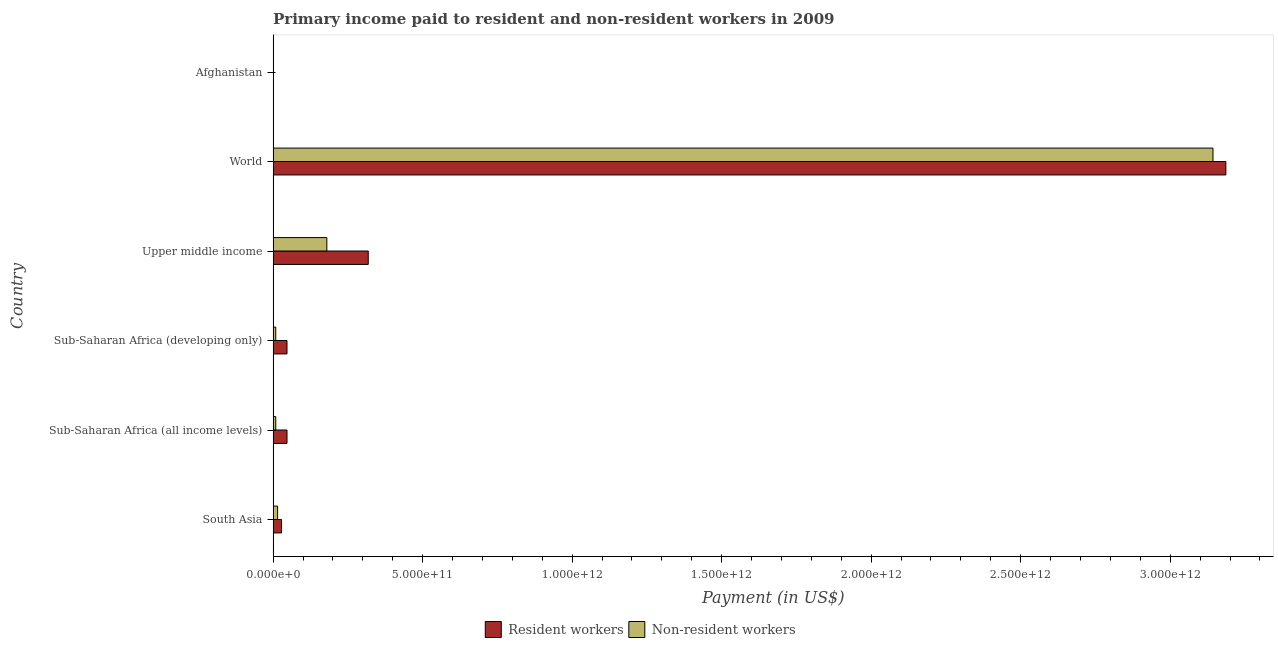How many groups of bars are there?
Offer a very short reply. 6. How many bars are there on the 1st tick from the top?
Provide a short and direct response. 2. What is the label of the 1st group of bars from the top?
Keep it short and to the point. Afghanistan. In how many cases, is the number of bars for a given country not equal to the number of legend labels?
Ensure brevity in your answer.  0. What is the payment made to non-resident workers in Sub-Saharan Africa (all income levels)?
Your response must be concise. 8.85e+09. Across all countries, what is the maximum payment made to resident workers?
Your answer should be very brief. 3.19e+12. Across all countries, what is the minimum payment made to resident workers?
Keep it short and to the point. 1.66e+08. In which country was the payment made to non-resident workers maximum?
Keep it short and to the point. World. In which country was the payment made to non-resident workers minimum?
Give a very brief answer. Afghanistan. What is the total payment made to resident workers in the graph?
Your answer should be very brief. 3.63e+12. What is the difference between the payment made to resident workers in South Asia and that in Upper middle income?
Offer a terse response. -2.90e+11. What is the difference between the payment made to resident workers in World and the payment made to non-resident workers in Sub-Saharan Africa (all income levels)?
Your answer should be very brief. 3.18e+12. What is the average payment made to non-resident workers per country?
Your answer should be very brief. 5.59e+11. What is the difference between the payment made to non-resident workers and payment made to resident workers in Afghanistan?
Provide a succinct answer. 8.03e+07. In how many countries, is the payment made to non-resident workers greater than 2500000000000 US$?
Ensure brevity in your answer.  1. What is the ratio of the payment made to resident workers in Sub-Saharan Africa (all income levels) to that in Sub-Saharan Africa (developing only)?
Offer a very short reply. 1. Is the payment made to non-resident workers in Afghanistan less than that in Sub-Saharan Africa (all income levels)?
Ensure brevity in your answer.  Yes. What is the difference between the highest and the second highest payment made to resident workers?
Your answer should be very brief. 2.87e+12. What is the difference between the highest and the lowest payment made to non-resident workers?
Provide a short and direct response. 3.14e+12. Is the sum of the payment made to non-resident workers in Sub-Saharan Africa (all income levels) and World greater than the maximum payment made to resident workers across all countries?
Offer a terse response. No. What does the 1st bar from the top in Sub-Saharan Africa (developing only) represents?
Provide a short and direct response. Non-resident workers. What does the 1st bar from the bottom in Sub-Saharan Africa (all income levels) represents?
Provide a short and direct response. Resident workers. How many bars are there?
Offer a very short reply. 12. What is the difference between two consecutive major ticks on the X-axis?
Make the answer very short. 5.00e+11. Are the values on the major ticks of X-axis written in scientific E-notation?
Offer a terse response. Yes. Does the graph contain grids?
Your answer should be compact. No. What is the title of the graph?
Your answer should be very brief. Primary income paid to resident and non-resident workers in 2009. Does "Male labourers" appear as one of the legend labels in the graph?
Provide a short and direct response. No. What is the label or title of the X-axis?
Provide a short and direct response. Payment (in US$). What is the label or title of the Y-axis?
Provide a succinct answer. Country. What is the Payment (in US$) of Resident workers in South Asia?
Provide a succinct answer. 2.81e+1. What is the Payment (in US$) of Non-resident workers in South Asia?
Ensure brevity in your answer.  1.50e+1. What is the Payment (in US$) of Resident workers in Sub-Saharan Africa (all income levels)?
Offer a terse response. 4.64e+1. What is the Payment (in US$) of Non-resident workers in Sub-Saharan Africa (all income levels)?
Offer a terse response. 8.85e+09. What is the Payment (in US$) of Resident workers in Sub-Saharan Africa (developing only)?
Ensure brevity in your answer.  4.64e+1. What is the Payment (in US$) in Non-resident workers in Sub-Saharan Africa (developing only)?
Provide a succinct answer. 8.85e+09. What is the Payment (in US$) of Resident workers in Upper middle income?
Provide a succinct answer. 3.18e+11. What is the Payment (in US$) of Non-resident workers in Upper middle income?
Offer a terse response. 1.80e+11. What is the Payment (in US$) of Resident workers in World?
Your response must be concise. 3.19e+12. What is the Payment (in US$) in Non-resident workers in World?
Provide a short and direct response. 3.14e+12. What is the Payment (in US$) of Resident workers in Afghanistan?
Keep it short and to the point. 1.66e+08. What is the Payment (in US$) in Non-resident workers in Afghanistan?
Ensure brevity in your answer.  2.46e+08. Across all countries, what is the maximum Payment (in US$) of Resident workers?
Your answer should be compact. 3.19e+12. Across all countries, what is the maximum Payment (in US$) of Non-resident workers?
Make the answer very short. 3.14e+12. Across all countries, what is the minimum Payment (in US$) of Resident workers?
Ensure brevity in your answer.  1.66e+08. Across all countries, what is the minimum Payment (in US$) of Non-resident workers?
Make the answer very short. 2.46e+08. What is the total Payment (in US$) of Resident workers in the graph?
Offer a terse response. 3.63e+12. What is the total Payment (in US$) in Non-resident workers in the graph?
Ensure brevity in your answer.  3.36e+12. What is the difference between the Payment (in US$) of Resident workers in South Asia and that in Sub-Saharan Africa (all income levels)?
Your answer should be very brief. -1.83e+1. What is the difference between the Payment (in US$) of Non-resident workers in South Asia and that in Sub-Saharan Africa (all income levels)?
Provide a succinct answer. 6.14e+09. What is the difference between the Payment (in US$) in Resident workers in South Asia and that in Sub-Saharan Africa (developing only)?
Keep it short and to the point. -1.83e+1. What is the difference between the Payment (in US$) in Non-resident workers in South Asia and that in Sub-Saharan Africa (developing only)?
Provide a short and direct response. 6.14e+09. What is the difference between the Payment (in US$) of Resident workers in South Asia and that in Upper middle income?
Provide a succinct answer. -2.90e+11. What is the difference between the Payment (in US$) of Non-resident workers in South Asia and that in Upper middle income?
Provide a succinct answer. -1.65e+11. What is the difference between the Payment (in US$) in Resident workers in South Asia and that in World?
Make the answer very short. -3.16e+12. What is the difference between the Payment (in US$) of Non-resident workers in South Asia and that in World?
Provide a succinct answer. -3.13e+12. What is the difference between the Payment (in US$) of Resident workers in South Asia and that in Afghanistan?
Offer a very short reply. 2.79e+1. What is the difference between the Payment (in US$) in Non-resident workers in South Asia and that in Afghanistan?
Give a very brief answer. 1.47e+1. What is the difference between the Payment (in US$) of Resident workers in Sub-Saharan Africa (all income levels) and that in Sub-Saharan Africa (developing only)?
Your response must be concise. 5.84e+07. What is the difference between the Payment (in US$) of Non-resident workers in Sub-Saharan Africa (all income levels) and that in Sub-Saharan Africa (developing only)?
Make the answer very short. 3.65e+06. What is the difference between the Payment (in US$) in Resident workers in Sub-Saharan Africa (all income levels) and that in Upper middle income?
Provide a short and direct response. -2.72e+11. What is the difference between the Payment (in US$) of Non-resident workers in Sub-Saharan Africa (all income levels) and that in Upper middle income?
Offer a terse response. -1.71e+11. What is the difference between the Payment (in US$) in Resident workers in Sub-Saharan Africa (all income levels) and that in World?
Provide a short and direct response. -3.14e+12. What is the difference between the Payment (in US$) in Non-resident workers in Sub-Saharan Africa (all income levels) and that in World?
Your answer should be compact. -3.13e+12. What is the difference between the Payment (in US$) of Resident workers in Sub-Saharan Africa (all income levels) and that in Afghanistan?
Ensure brevity in your answer.  4.63e+1. What is the difference between the Payment (in US$) of Non-resident workers in Sub-Saharan Africa (all income levels) and that in Afghanistan?
Keep it short and to the point. 8.60e+09. What is the difference between the Payment (in US$) of Resident workers in Sub-Saharan Africa (developing only) and that in Upper middle income?
Make the answer very short. -2.72e+11. What is the difference between the Payment (in US$) of Non-resident workers in Sub-Saharan Africa (developing only) and that in Upper middle income?
Ensure brevity in your answer.  -1.71e+11. What is the difference between the Payment (in US$) in Resident workers in Sub-Saharan Africa (developing only) and that in World?
Provide a short and direct response. -3.14e+12. What is the difference between the Payment (in US$) of Non-resident workers in Sub-Saharan Africa (developing only) and that in World?
Keep it short and to the point. -3.13e+12. What is the difference between the Payment (in US$) in Resident workers in Sub-Saharan Africa (developing only) and that in Afghanistan?
Provide a succinct answer. 4.62e+1. What is the difference between the Payment (in US$) of Non-resident workers in Sub-Saharan Africa (developing only) and that in Afghanistan?
Your answer should be compact. 8.60e+09. What is the difference between the Payment (in US$) in Resident workers in Upper middle income and that in World?
Keep it short and to the point. -2.87e+12. What is the difference between the Payment (in US$) in Non-resident workers in Upper middle income and that in World?
Offer a very short reply. -2.96e+12. What is the difference between the Payment (in US$) in Resident workers in Upper middle income and that in Afghanistan?
Give a very brief answer. 3.18e+11. What is the difference between the Payment (in US$) of Non-resident workers in Upper middle income and that in Afghanistan?
Your answer should be compact. 1.79e+11. What is the difference between the Payment (in US$) of Resident workers in World and that in Afghanistan?
Offer a terse response. 3.19e+12. What is the difference between the Payment (in US$) in Non-resident workers in World and that in Afghanistan?
Offer a very short reply. 3.14e+12. What is the difference between the Payment (in US$) in Resident workers in South Asia and the Payment (in US$) in Non-resident workers in Sub-Saharan Africa (all income levels)?
Make the answer very short. 1.92e+1. What is the difference between the Payment (in US$) of Resident workers in South Asia and the Payment (in US$) of Non-resident workers in Sub-Saharan Africa (developing only)?
Provide a short and direct response. 1.92e+1. What is the difference between the Payment (in US$) of Resident workers in South Asia and the Payment (in US$) of Non-resident workers in Upper middle income?
Your response must be concise. -1.52e+11. What is the difference between the Payment (in US$) in Resident workers in South Asia and the Payment (in US$) in Non-resident workers in World?
Your answer should be compact. -3.12e+12. What is the difference between the Payment (in US$) in Resident workers in South Asia and the Payment (in US$) in Non-resident workers in Afghanistan?
Your answer should be compact. 2.78e+1. What is the difference between the Payment (in US$) of Resident workers in Sub-Saharan Africa (all income levels) and the Payment (in US$) of Non-resident workers in Sub-Saharan Africa (developing only)?
Provide a short and direct response. 3.76e+1. What is the difference between the Payment (in US$) of Resident workers in Sub-Saharan Africa (all income levels) and the Payment (in US$) of Non-resident workers in Upper middle income?
Provide a succinct answer. -1.33e+11. What is the difference between the Payment (in US$) in Resident workers in Sub-Saharan Africa (all income levels) and the Payment (in US$) in Non-resident workers in World?
Provide a short and direct response. -3.10e+12. What is the difference between the Payment (in US$) of Resident workers in Sub-Saharan Africa (all income levels) and the Payment (in US$) of Non-resident workers in Afghanistan?
Offer a very short reply. 4.62e+1. What is the difference between the Payment (in US$) of Resident workers in Sub-Saharan Africa (developing only) and the Payment (in US$) of Non-resident workers in Upper middle income?
Provide a succinct answer. -1.33e+11. What is the difference between the Payment (in US$) in Resident workers in Sub-Saharan Africa (developing only) and the Payment (in US$) in Non-resident workers in World?
Ensure brevity in your answer.  -3.10e+12. What is the difference between the Payment (in US$) in Resident workers in Sub-Saharan Africa (developing only) and the Payment (in US$) in Non-resident workers in Afghanistan?
Your response must be concise. 4.61e+1. What is the difference between the Payment (in US$) in Resident workers in Upper middle income and the Payment (in US$) in Non-resident workers in World?
Ensure brevity in your answer.  -2.82e+12. What is the difference between the Payment (in US$) in Resident workers in Upper middle income and the Payment (in US$) in Non-resident workers in Afghanistan?
Offer a terse response. 3.18e+11. What is the difference between the Payment (in US$) of Resident workers in World and the Payment (in US$) of Non-resident workers in Afghanistan?
Your answer should be compact. 3.19e+12. What is the average Payment (in US$) of Resident workers per country?
Keep it short and to the point. 6.04e+11. What is the average Payment (in US$) of Non-resident workers per country?
Your response must be concise. 5.59e+11. What is the difference between the Payment (in US$) in Resident workers and Payment (in US$) in Non-resident workers in South Asia?
Offer a terse response. 1.31e+1. What is the difference between the Payment (in US$) in Resident workers and Payment (in US$) in Non-resident workers in Sub-Saharan Africa (all income levels)?
Ensure brevity in your answer.  3.76e+1. What is the difference between the Payment (in US$) in Resident workers and Payment (in US$) in Non-resident workers in Sub-Saharan Africa (developing only)?
Your answer should be compact. 3.75e+1. What is the difference between the Payment (in US$) in Resident workers and Payment (in US$) in Non-resident workers in Upper middle income?
Your answer should be compact. 1.38e+11. What is the difference between the Payment (in US$) of Resident workers and Payment (in US$) of Non-resident workers in World?
Make the answer very short. 4.30e+1. What is the difference between the Payment (in US$) of Resident workers and Payment (in US$) of Non-resident workers in Afghanistan?
Ensure brevity in your answer.  -8.03e+07. What is the ratio of the Payment (in US$) of Resident workers in South Asia to that in Sub-Saharan Africa (all income levels)?
Make the answer very short. 0.6. What is the ratio of the Payment (in US$) of Non-resident workers in South Asia to that in Sub-Saharan Africa (all income levels)?
Offer a terse response. 1.69. What is the ratio of the Payment (in US$) of Resident workers in South Asia to that in Sub-Saharan Africa (developing only)?
Your answer should be very brief. 0.61. What is the ratio of the Payment (in US$) in Non-resident workers in South Asia to that in Sub-Saharan Africa (developing only)?
Provide a succinct answer. 1.69. What is the ratio of the Payment (in US$) in Resident workers in South Asia to that in Upper middle income?
Offer a terse response. 0.09. What is the ratio of the Payment (in US$) in Non-resident workers in South Asia to that in Upper middle income?
Provide a succinct answer. 0.08. What is the ratio of the Payment (in US$) of Resident workers in South Asia to that in World?
Your response must be concise. 0.01. What is the ratio of the Payment (in US$) in Non-resident workers in South Asia to that in World?
Provide a short and direct response. 0. What is the ratio of the Payment (in US$) in Resident workers in South Asia to that in Afghanistan?
Offer a very short reply. 169.36. What is the ratio of the Payment (in US$) in Non-resident workers in South Asia to that in Afghanistan?
Keep it short and to the point. 60.88. What is the ratio of the Payment (in US$) of Resident workers in Sub-Saharan Africa (all income levels) to that in Sub-Saharan Africa (developing only)?
Make the answer very short. 1. What is the ratio of the Payment (in US$) in Resident workers in Sub-Saharan Africa (all income levels) to that in Upper middle income?
Make the answer very short. 0.15. What is the ratio of the Payment (in US$) of Non-resident workers in Sub-Saharan Africa (all income levels) to that in Upper middle income?
Make the answer very short. 0.05. What is the ratio of the Payment (in US$) in Resident workers in Sub-Saharan Africa (all income levels) to that in World?
Your answer should be very brief. 0.01. What is the ratio of the Payment (in US$) in Non-resident workers in Sub-Saharan Africa (all income levels) to that in World?
Your answer should be compact. 0. What is the ratio of the Payment (in US$) of Resident workers in Sub-Saharan Africa (all income levels) to that in Afghanistan?
Give a very brief answer. 279.98. What is the ratio of the Payment (in US$) in Non-resident workers in Sub-Saharan Africa (all income levels) to that in Afghanistan?
Keep it short and to the point. 35.95. What is the ratio of the Payment (in US$) of Resident workers in Sub-Saharan Africa (developing only) to that in Upper middle income?
Offer a very short reply. 0.15. What is the ratio of the Payment (in US$) in Non-resident workers in Sub-Saharan Africa (developing only) to that in Upper middle income?
Keep it short and to the point. 0.05. What is the ratio of the Payment (in US$) in Resident workers in Sub-Saharan Africa (developing only) to that in World?
Offer a very short reply. 0.01. What is the ratio of the Payment (in US$) of Non-resident workers in Sub-Saharan Africa (developing only) to that in World?
Offer a very short reply. 0. What is the ratio of the Payment (in US$) in Resident workers in Sub-Saharan Africa (developing only) to that in Afghanistan?
Provide a succinct answer. 279.62. What is the ratio of the Payment (in US$) of Non-resident workers in Sub-Saharan Africa (developing only) to that in Afghanistan?
Ensure brevity in your answer.  35.93. What is the ratio of the Payment (in US$) in Resident workers in Upper middle income to that in World?
Offer a very short reply. 0.1. What is the ratio of the Payment (in US$) of Non-resident workers in Upper middle income to that in World?
Give a very brief answer. 0.06. What is the ratio of the Payment (in US$) in Resident workers in Upper middle income to that in Afghanistan?
Give a very brief answer. 1918.04. What is the ratio of the Payment (in US$) in Non-resident workers in Upper middle income to that in Afghanistan?
Your response must be concise. 729.96. What is the ratio of the Payment (in US$) in Resident workers in World to that in Afghanistan?
Your response must be concise. 1.92e+04. What is the ratio of the Payment (in US$) in Non-resident workers in World to that in Afghanistan?
Make the answer very short. 1.28e+04. What is the difference between the highest and the second highest Payment (in US$) of Resident workers?
Offer a terse response. 2.87e+12. What is the difference between the highest and the second highest Payment (in US$) of Non-resident workers?
Your answer should be very brief. 2.96e+12. What is the difference between the highest and the lowest Payment (in US$) in Resident workers?
Offer a very short reply. 3.19e+12. What is the difference between the highest and the lowest Payment (in US$) of Non-resident workers?
Give a very brief answer. 3.14e+12. 